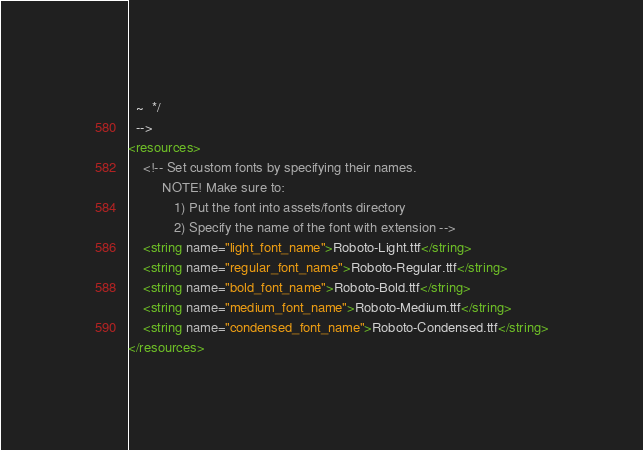<code> <loc_0><loc_0><loc_500><loc_500><_XML_>  ~  */
  -->
<resources>
    <!-- Set custom fonts by specifying their names.
         NOTE! Make sure to:
            1) Put the font into assets/fonts directory
            2) Specify the name of the font with extension -->
    <string name="light_font_name">Roboto-Light.ttf</string>
    <string name="regular_font_name">Roboto-Regular.ttf</string>
    <string name="bold_font_name">Roboto-Bold.ttf</string>
    <string name="medium_font_name">Roboto-Medium.ttf</string>
    <string name="condensed_font_name">Roboto-Condensed.ttf</string>
</resources></code> 